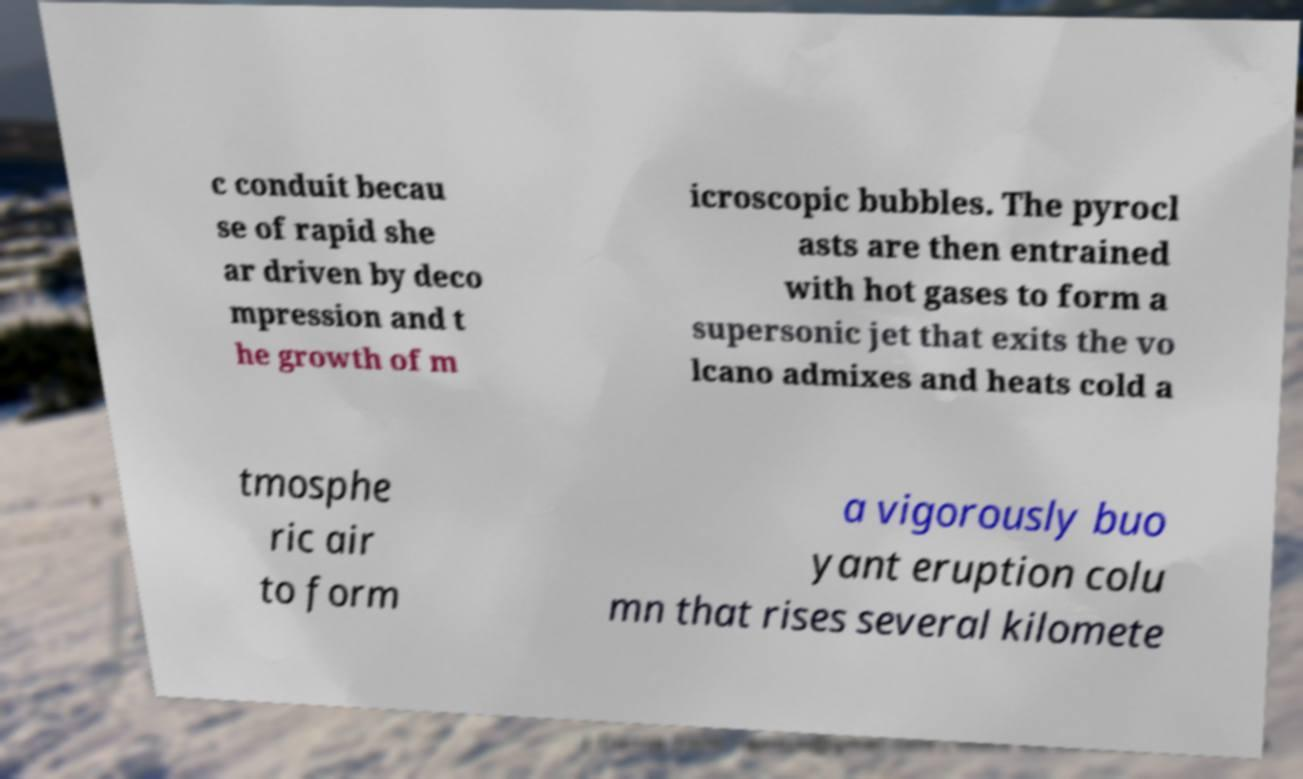Please read and relay the text visible in this image. What does it say? c conduit becau se of rapid she ar driven by deco mpression and t he growth of m icroscopic bubbles. The pyrocl asts are then entrained with hot gases to form a supersonic jet that exits the vo lcano admixes and heats cold a tmosphe ric air to form a vigorously buo yant eruption colu mn that rises several kilomete 